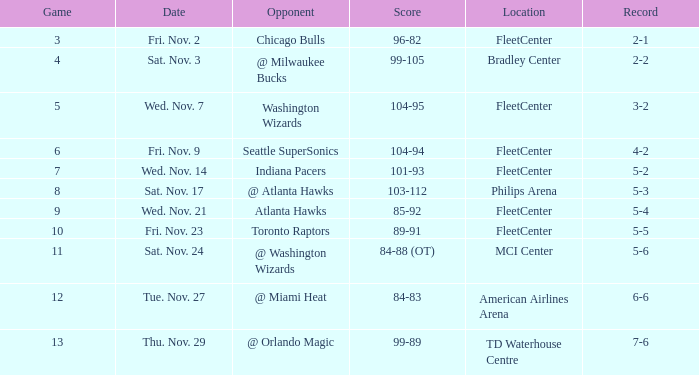What is the initial contest with a score of 99-89? 13.0. 